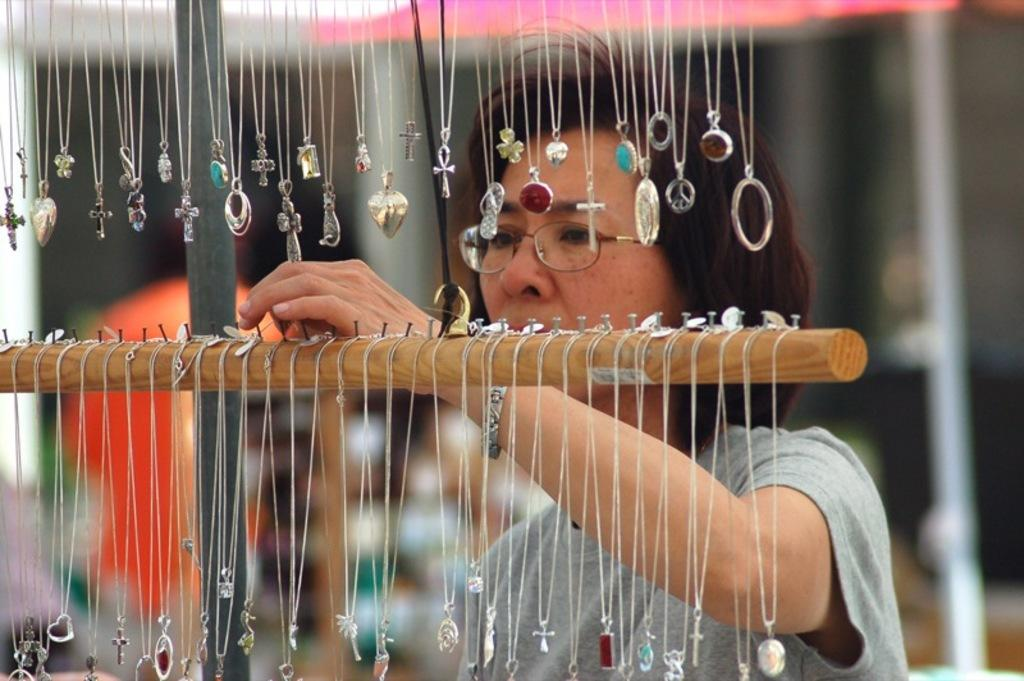What type of objects are hanging in the image? There are different kinds of chains in the image. How are the chains supported in the image? The chains are hanged on hangers. What are the hangers attached to in the image? The hangers are attached to hooks. Who is present in the image while observing the chains? A woman is watching the chains in the image. What type of toothbrush is the goat using in the image? There is no goat or toothbrush present in the image. 